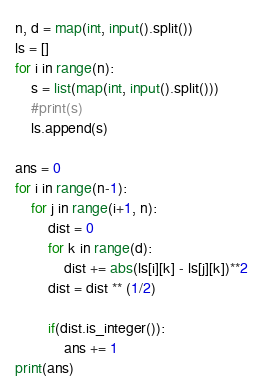<code> <loc_0><loc_0><loc_500><loc_500><_Python_>n, d = map(int, input().split())
ls = []
for i in range(n):
    s = list(map(int, input().split()))
    #print(s)
    ls.append(s)

ans = 0
for i in range(n-1):
    for j in range(i+1, n):
        dist = 0
        for k in range(d):
            dist += abs(ls[i][k] - ls[j][k])**2
        dist = dist ** (1/2)

        if(dist.is_integer()):
            ans += 1
print(ans)</code> 